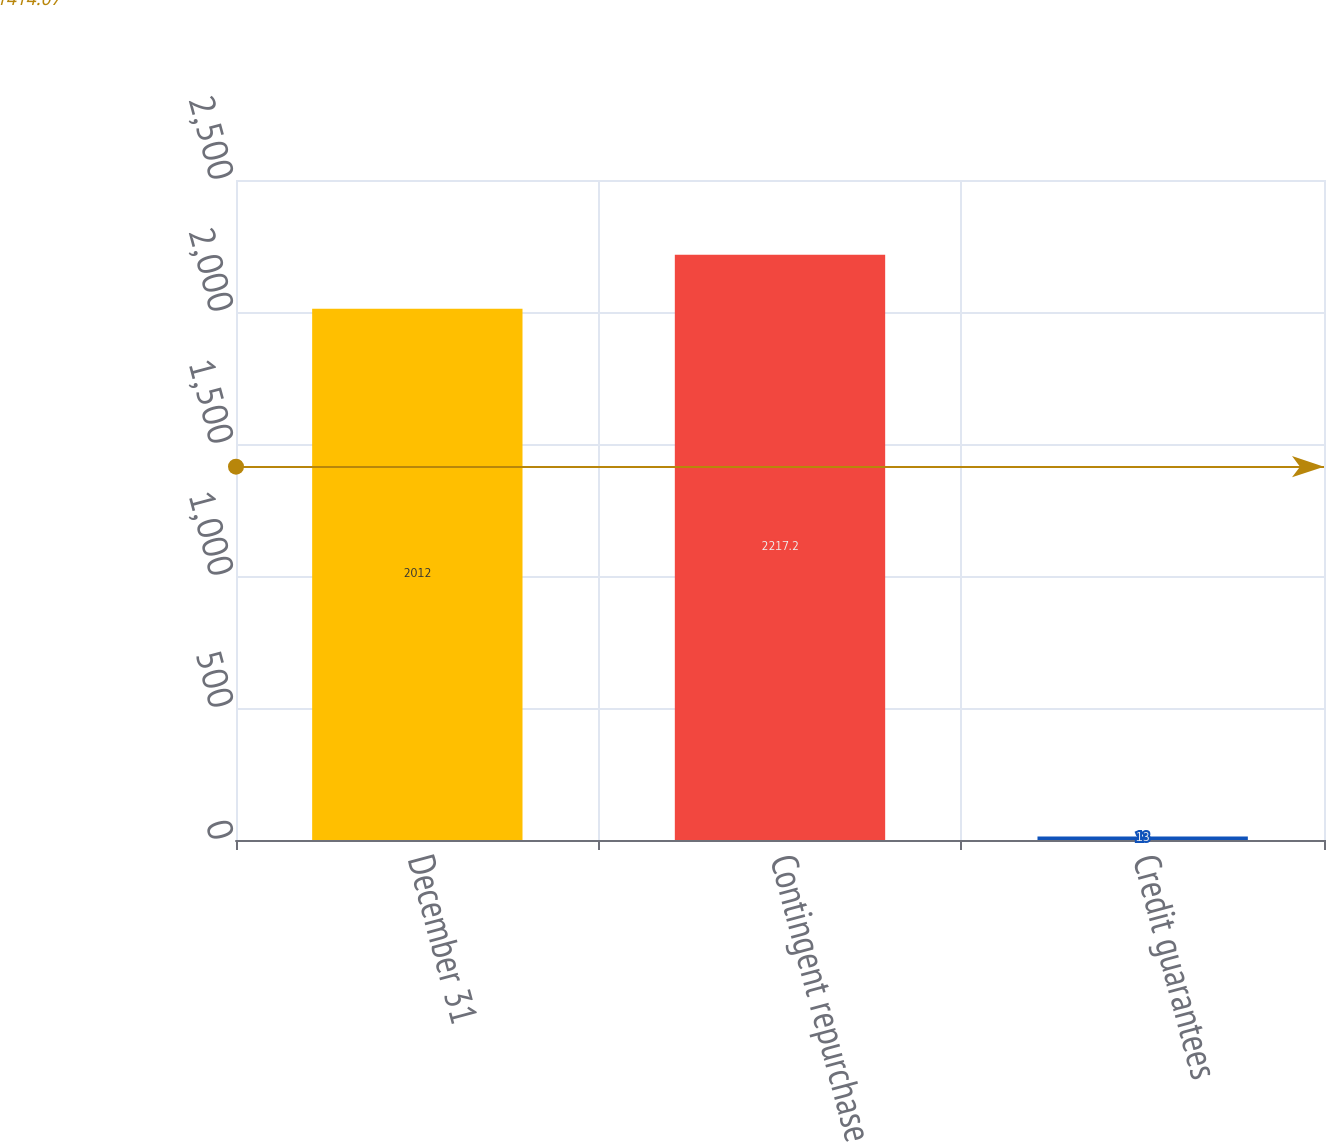Convert chart to OTSL. <chart><loc_0><loc_0><loc_500><loc_500><bar_chart><fcel>December 31<fcel>Contingent repurchase<fcel>Credit guarantees<nl><fcel>2012<fcel>2217.2<fcel>13<nl></chart> 